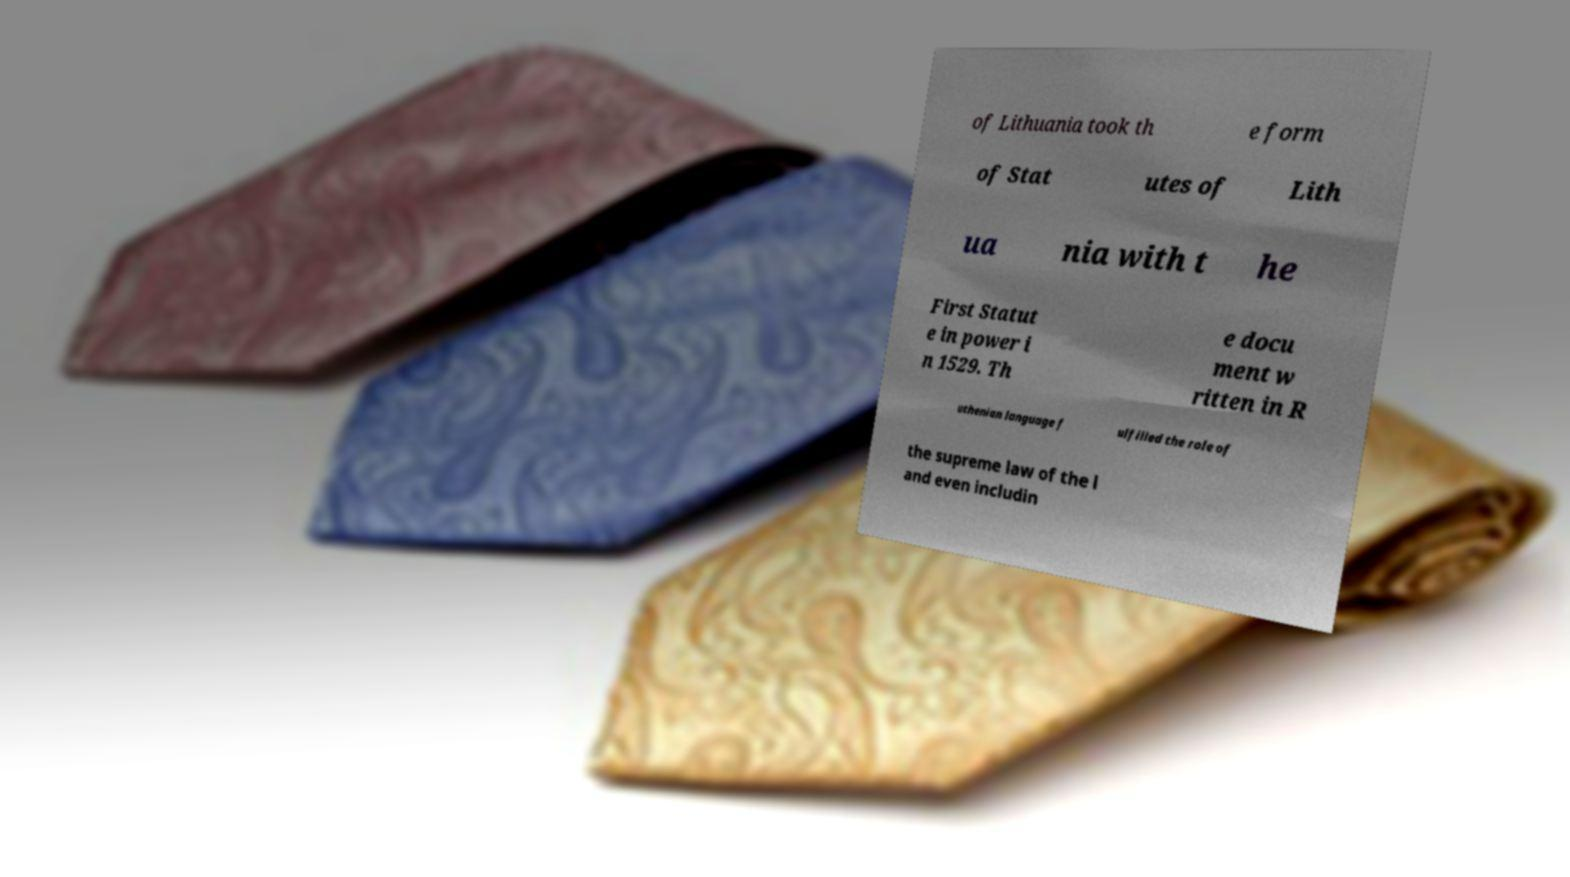What messages or text are displayed in this image? I need them in a readable, typed format. of Lithuania took th e form of Stat utes of Lith ua nia with t he First Statut e in power i n 1529. Th e docu ment w ritten in R uthenian language f ulfilled the role of the supreme law of the l and even includin 